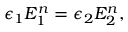<formula> <loc_0><loc_0><loc_500><loc_500>\epsilon _ { 1 } E _ { 1 } ^ { n } = \epsilon _ { 2 } E _ { 2 } ^ { n } ,</formula> 